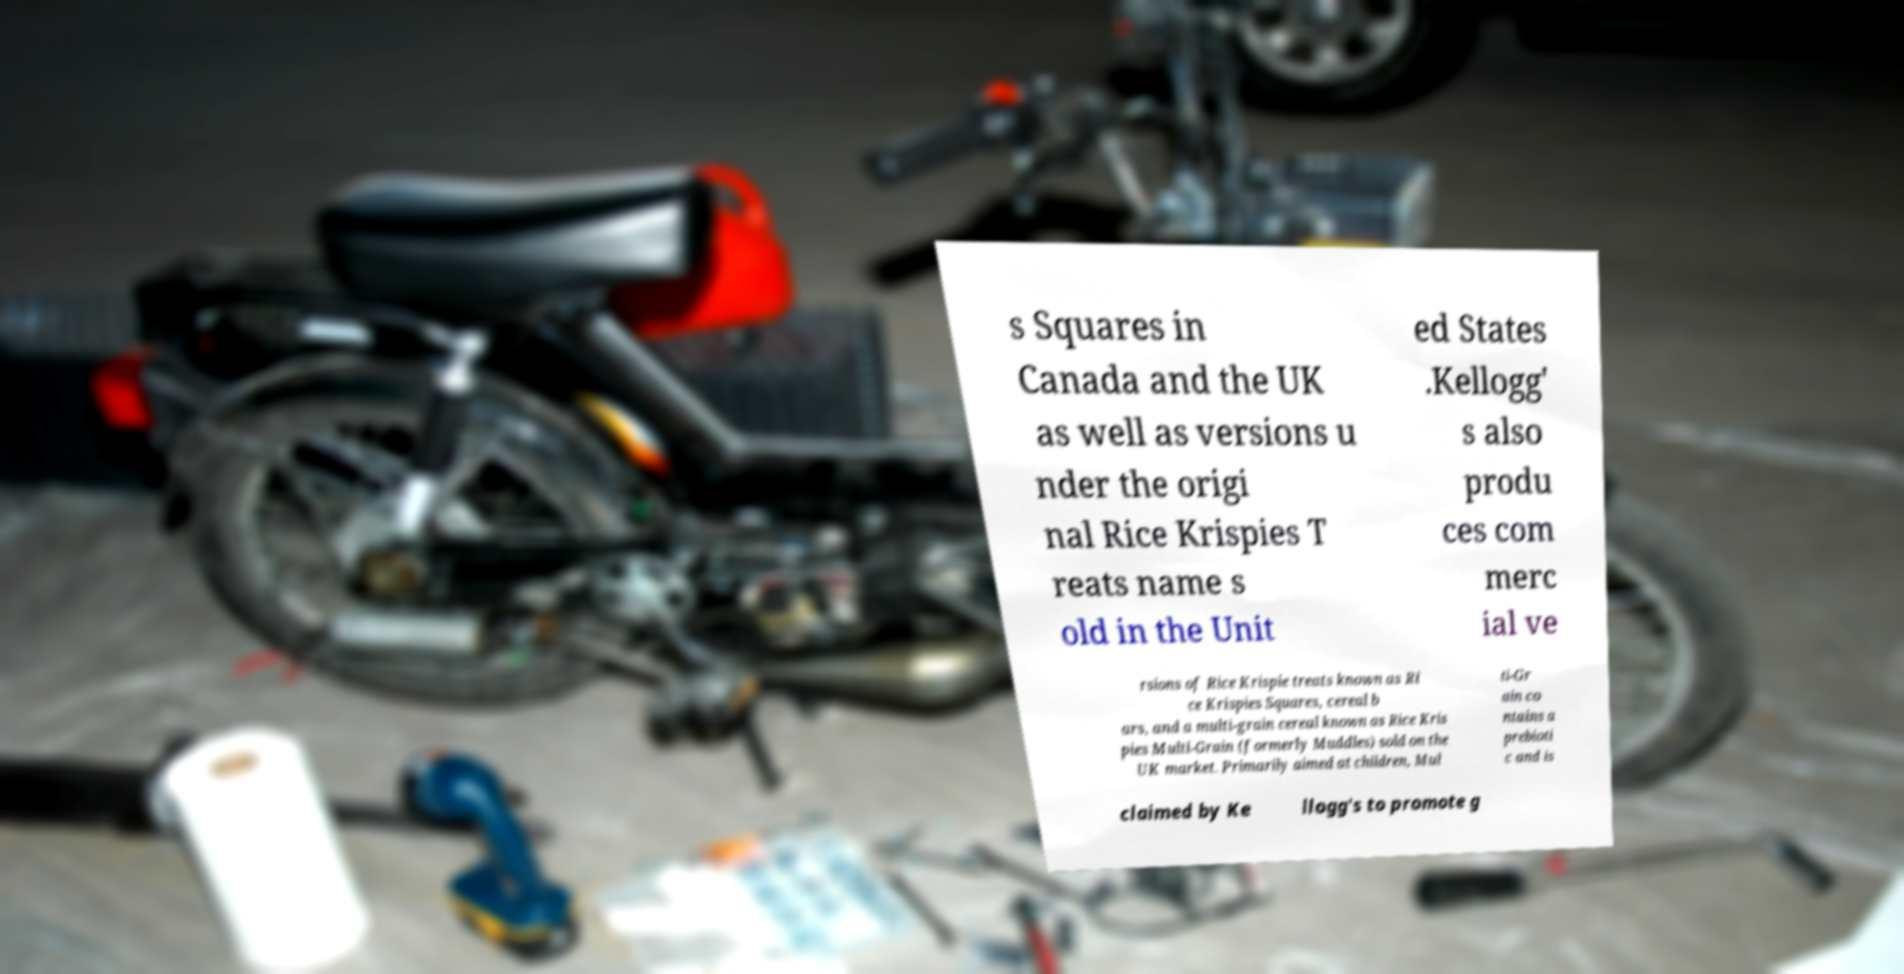I need the written content from this picture converted into text. Can you do that? s Squares in Canada and the UK as well as versions u nder the origi nal Rice Krispies T reats name s old in the Unit ed States .Kellogg' s also produ ces com merc ial ve rsions of Rice Krispie treats known as Ri ce Krispies Squares, cereal b ars, and a multi-grain cereal known as Rice Kris pies Multi-Grain (formerly Muddles) sold on the UK market. Primarily aimed at children, Mul ti-Gr ain co ntains a prebioti c and is claimed by Ke llogg's to promote g 